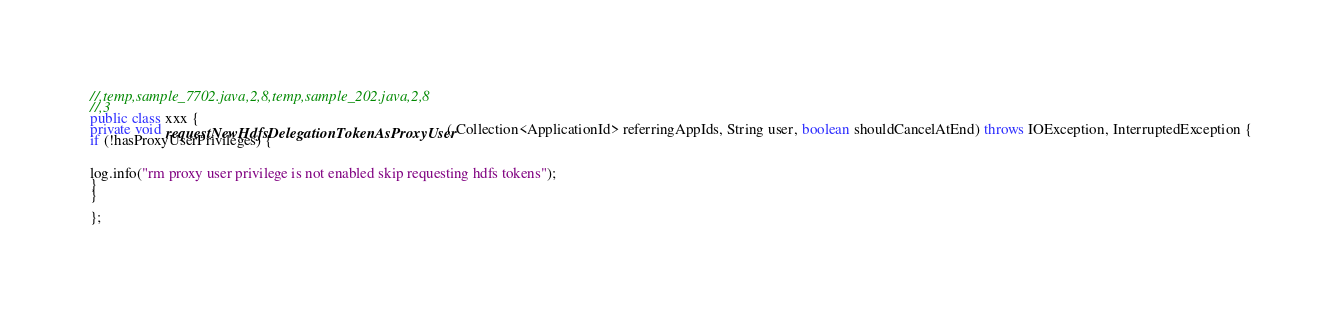Convert code to text. <code><loc_0><loc_0><loc_500><loc_500><_Java_>//,temp,sample_7702.java,2,8,temp,sample_202.java,2,8
//,3
public class xxx {
private void requestNewHdfsDelegationTokenAsProxyUser( Collection<ApplicationId> referringAppIds, String user, boolean shouldCancelAtEnd) throws IOException, InterruptedException {
if (!hasProxyUserPrivileges) {


log.info("rm proxy user privilege is not enabled skip requesting hdfs tokens");
}
}

};</code> 